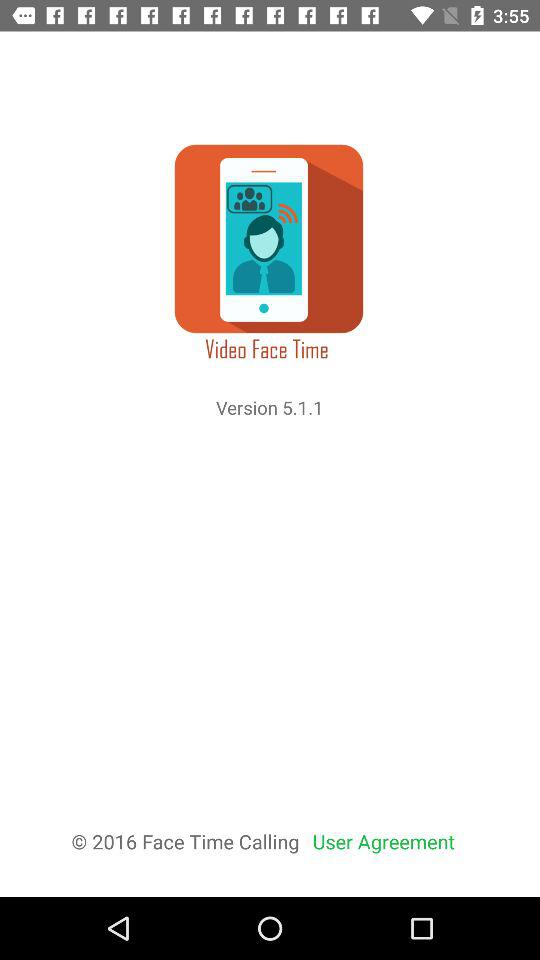What is the version? The version is 5.1.1. 